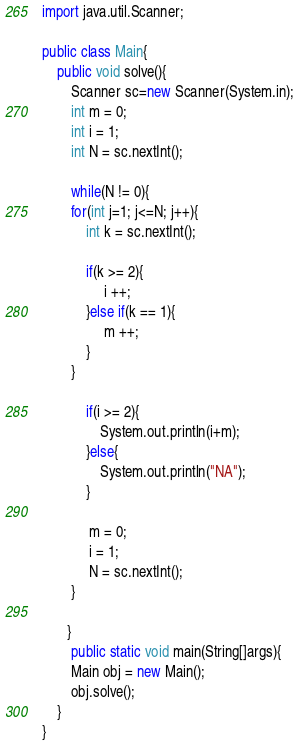Convert code to text. <code><loc_0><loc_0><loc_500><loc_500><_Java_>import java.util.Scanner;
  
public class Main{
    public void solve(){
        Scanner sc=new Scanner(System.in);
		int m = 0;
		int i = 1;
		int N = sc.nextInt();
		
        while(N != 0){
		for(int j=1; j<=N; j++){
			int k = sc.nextInt();
			
			if(k >= 2){
				 i ++;
			}else if(k == 1){
				 m ++;
			}
		}
			
			if(i >= 2){
				System.out.println(i+m);
			}else{
				System.out.println("NA");
			}
				
			 m = 0;
			 i = 1;
			 N = sc.nextInt();
		}
		
       }
        public static void main(String[]args){
        Main obj = new Main();
        obj.solve();
    }
}</code> 